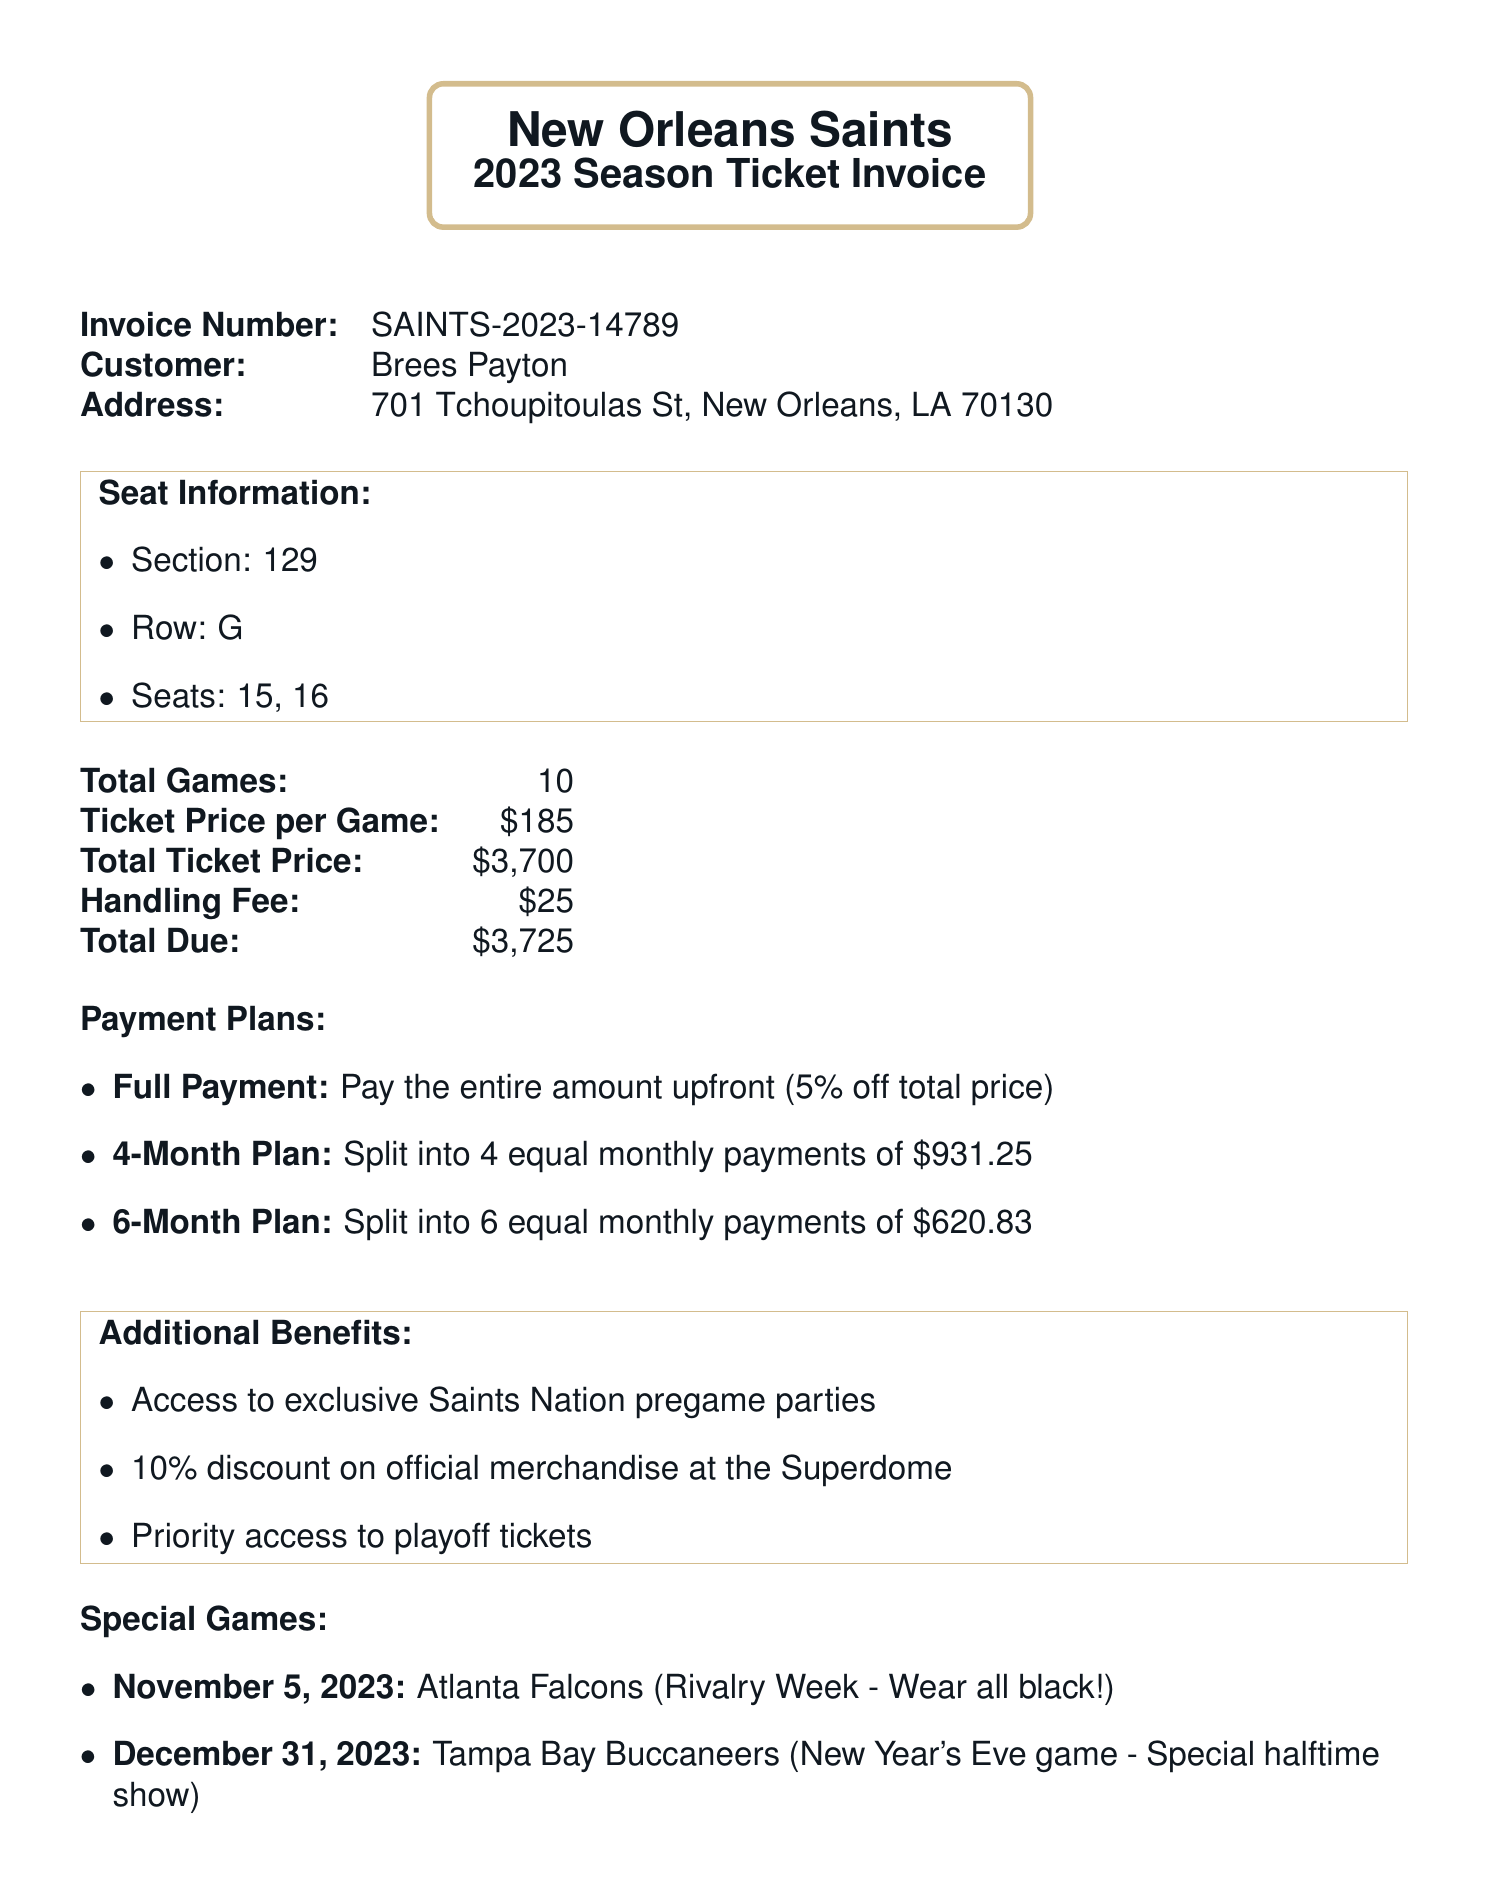What is the invoice number? The invoice number is specifically listed in the document as a unique identifier for the invoice.
Answer: SAINTS-2023-14789 Who is the customer? The customer's name is clearly stated in the document as the individual associated with the invoice.
Answer: Brees Payton How many total games are included in the season ticket? The document specifies the total number of games that the season ticket covers.
Answer: 10 What is the total due amount? The total due is prominently displayed in the invoice as the final amount to be paid.
Answer: $3725 What is the price per game? The ticket price per game is explicitly mentioned in the invoice, making it easy to identify.
Answer: $185 What are the payment options available? The document outlines several payment plans, indicating the flexibility offered to the customer.
Answer: Full Payment, 4-Month Plan, 6-Month Plan When is the game against the Atlanta Falcons? The date of the special game against the Atlanta Falcons is specified in the special games section.
Answer: November 5, 2023 What is one of the additional benefits included with the season ticket? The document lists several benefits that come with the season ticket, highlighting added value.
Answer: Access to exclusive Saints Nation pregame parties What is the handling fee? The specific charge for handling services is listed in the document, contributing to the total.
Answer: $25 What are the ticket terms regarding resale? The document outlines specific terms related to the resale of tickets, clarifying the resale policy for customers.
Answer: Resale allowed through official NFL Ticket Exchange only 